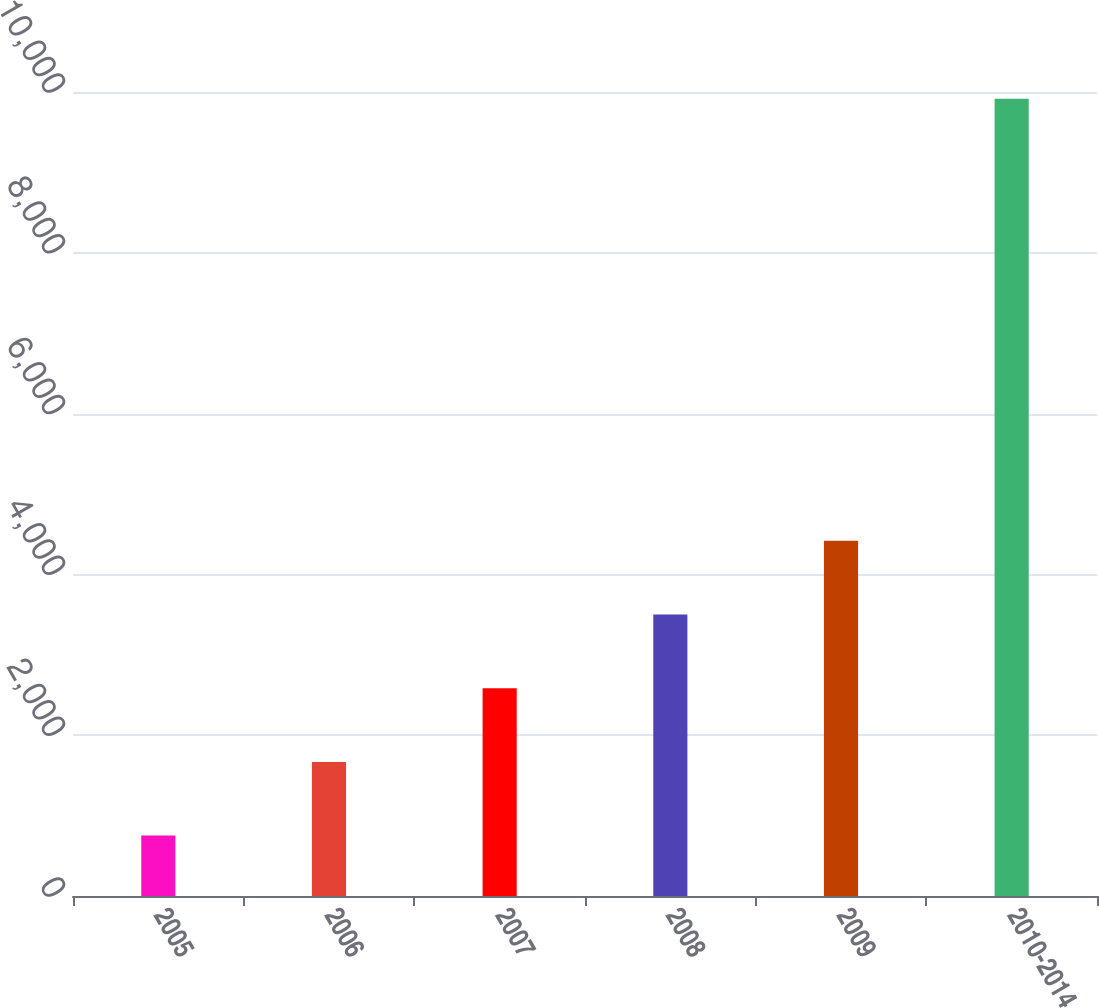<chart> <loc_0><loc_0><loc_500><loc_500><bar_chart><fcel>2005<fcel>2006<fcel>2007<fcel>2008<fcel>2009<fcel>2010-2014<nl><fcel>751<fcel>1667.5<fcel>2584<fcel>3500.5<fcel>4417<fcel>9916<nl></chart> 